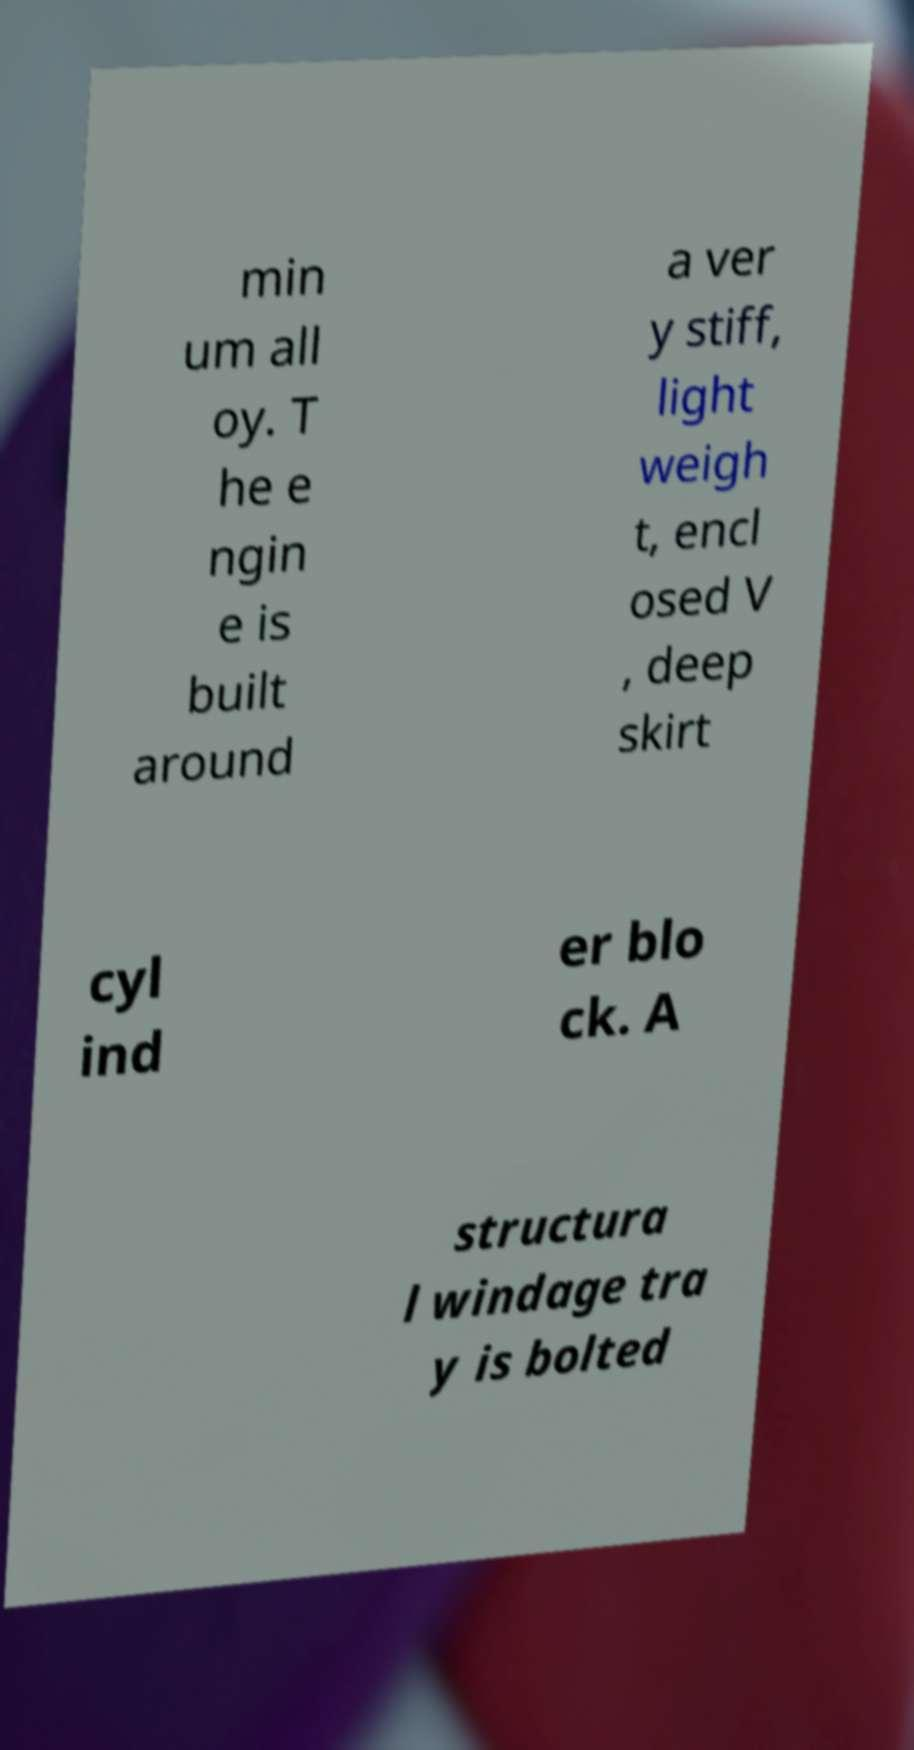Please identify and transcribe the text found in this image. min um all oy. T he e ngin e is built around a ver y stiff, light weigh t, encl osed V , deep skirt cyl ind er blo ck. A structura l windage tra y is bolted 